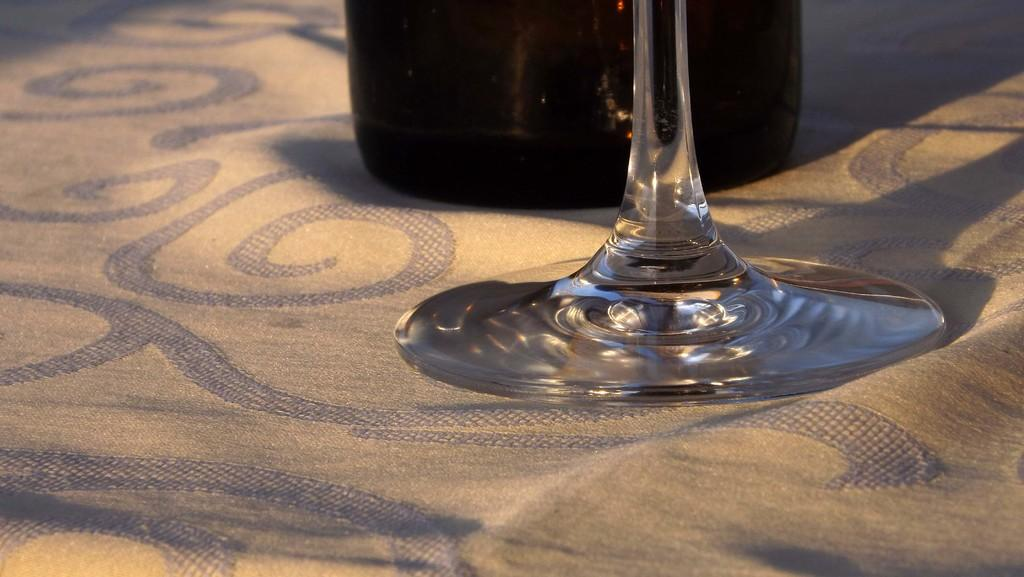What objects are present in the image? There is a bottle and a glass in the image. How are the bottle and glass positioned in the image? The bottle and glass are placed on a cloth. What might be the purpose of the bottle and glass in the image? They might be used for holding or serving a beverage. What type of cough can be heard coming from the bottle in the image? There is no sound, such as a cough, coming from the bottle in the image. 